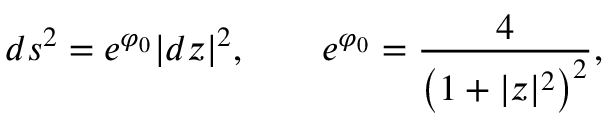Convert formula to latex. <formula><loc_0><loc_0><loc_500><loc_500>d s ^ { 2 } = e ^ { \varphi _ { 0 } } | d z | ^ { 2 } , \quad e ^ { \varphi _ { 0 } } = { \frac { 4 } { \left ( 1 + | z | ^ { 2 } \right ) ^ { 2 } } } ,</formula> 